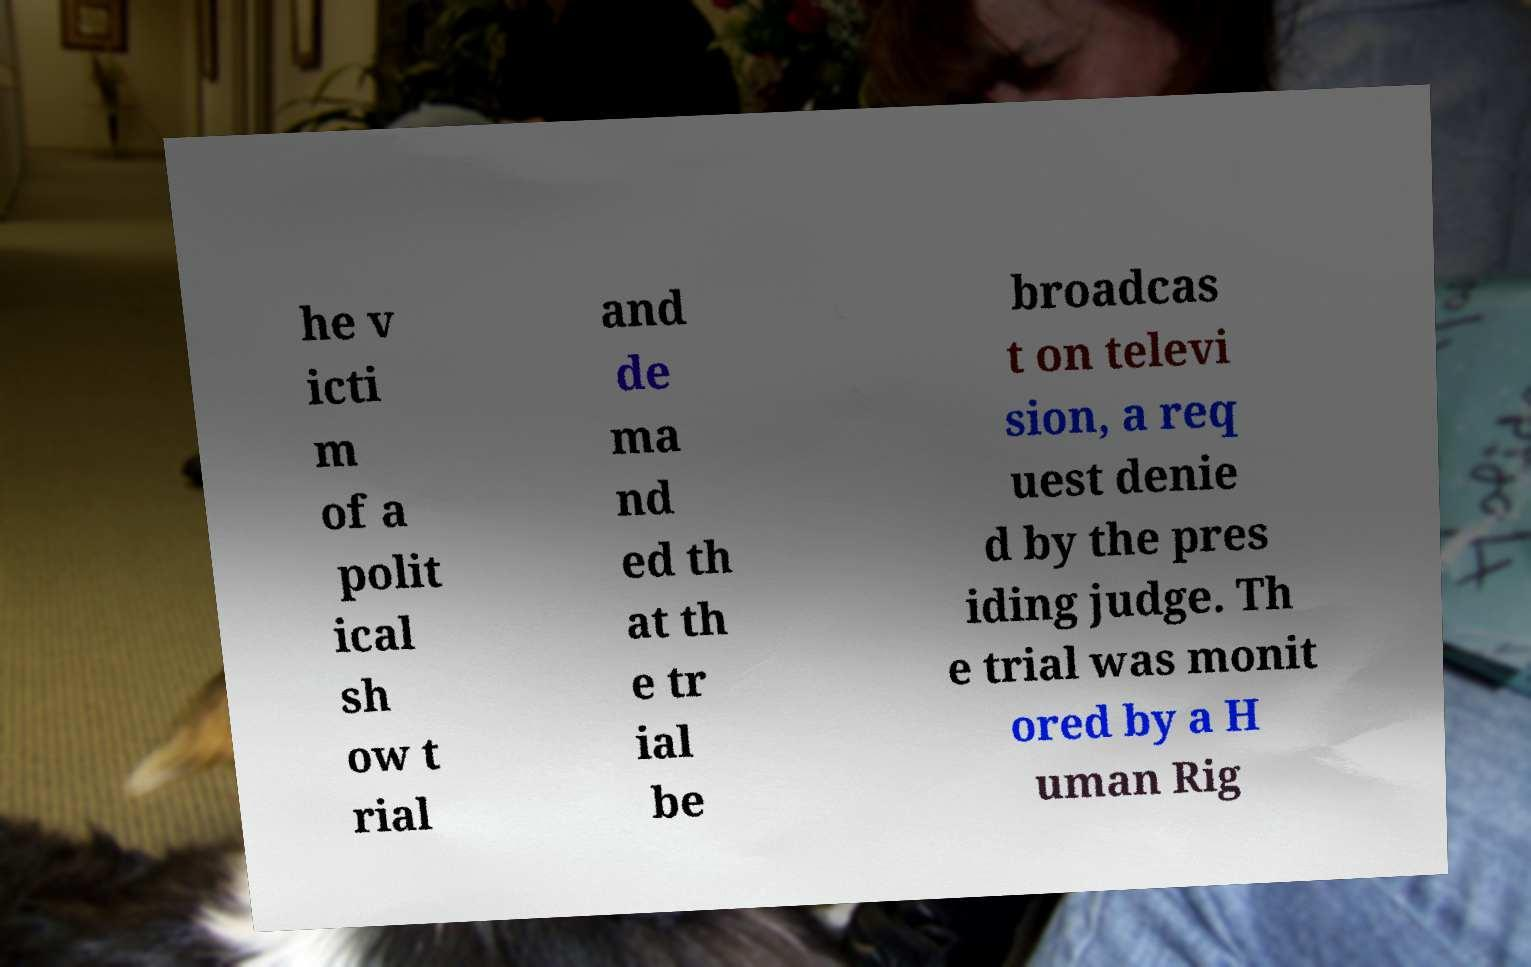Can you accurately transcribe the text from the provided image for me? he v icti m of a polit ical sh ow t rial and de ma nd ed th at th e tr ial be broadcas t on televi sion, a req uest denie d by the pres iding judge. Th e trial was monit ored by a H uman Rig 